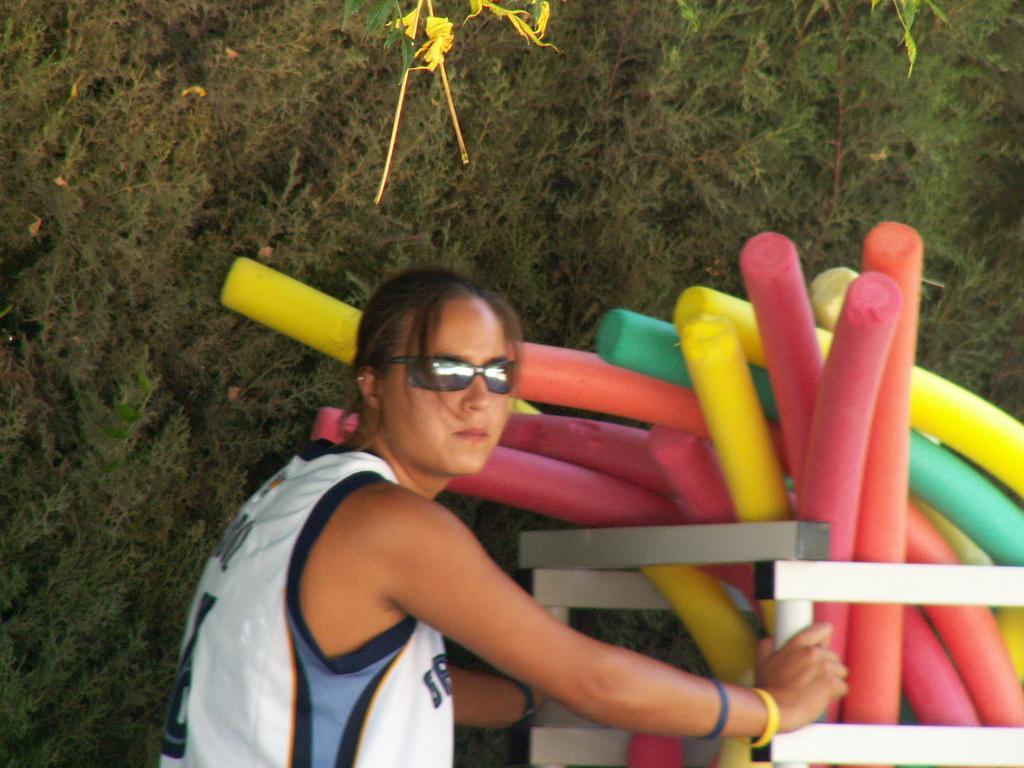Please provide a concise description of this image. In the picture I can see a person wearing white color T-shirt and glasses is standing here. Here I can see few objects which are in pink, red, yellow and green in color. In the background, I can see shrubs or trees. 